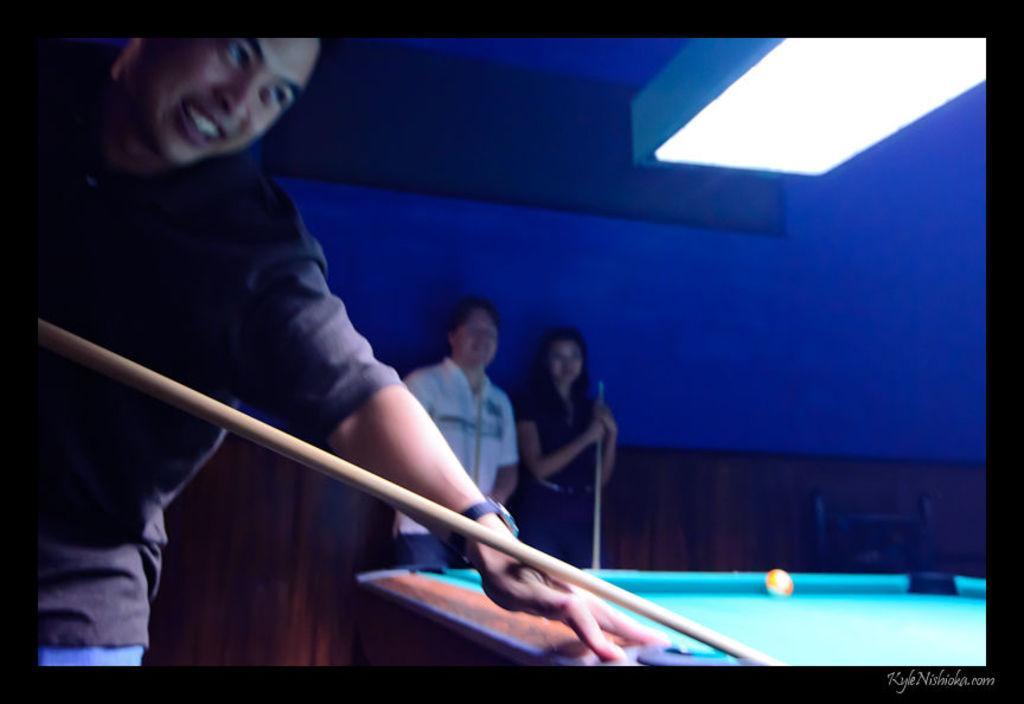Could you give a brief overview of what you see in this image? In this picture we can see persons,one person is holding a stick,here we can see a table and ball. 